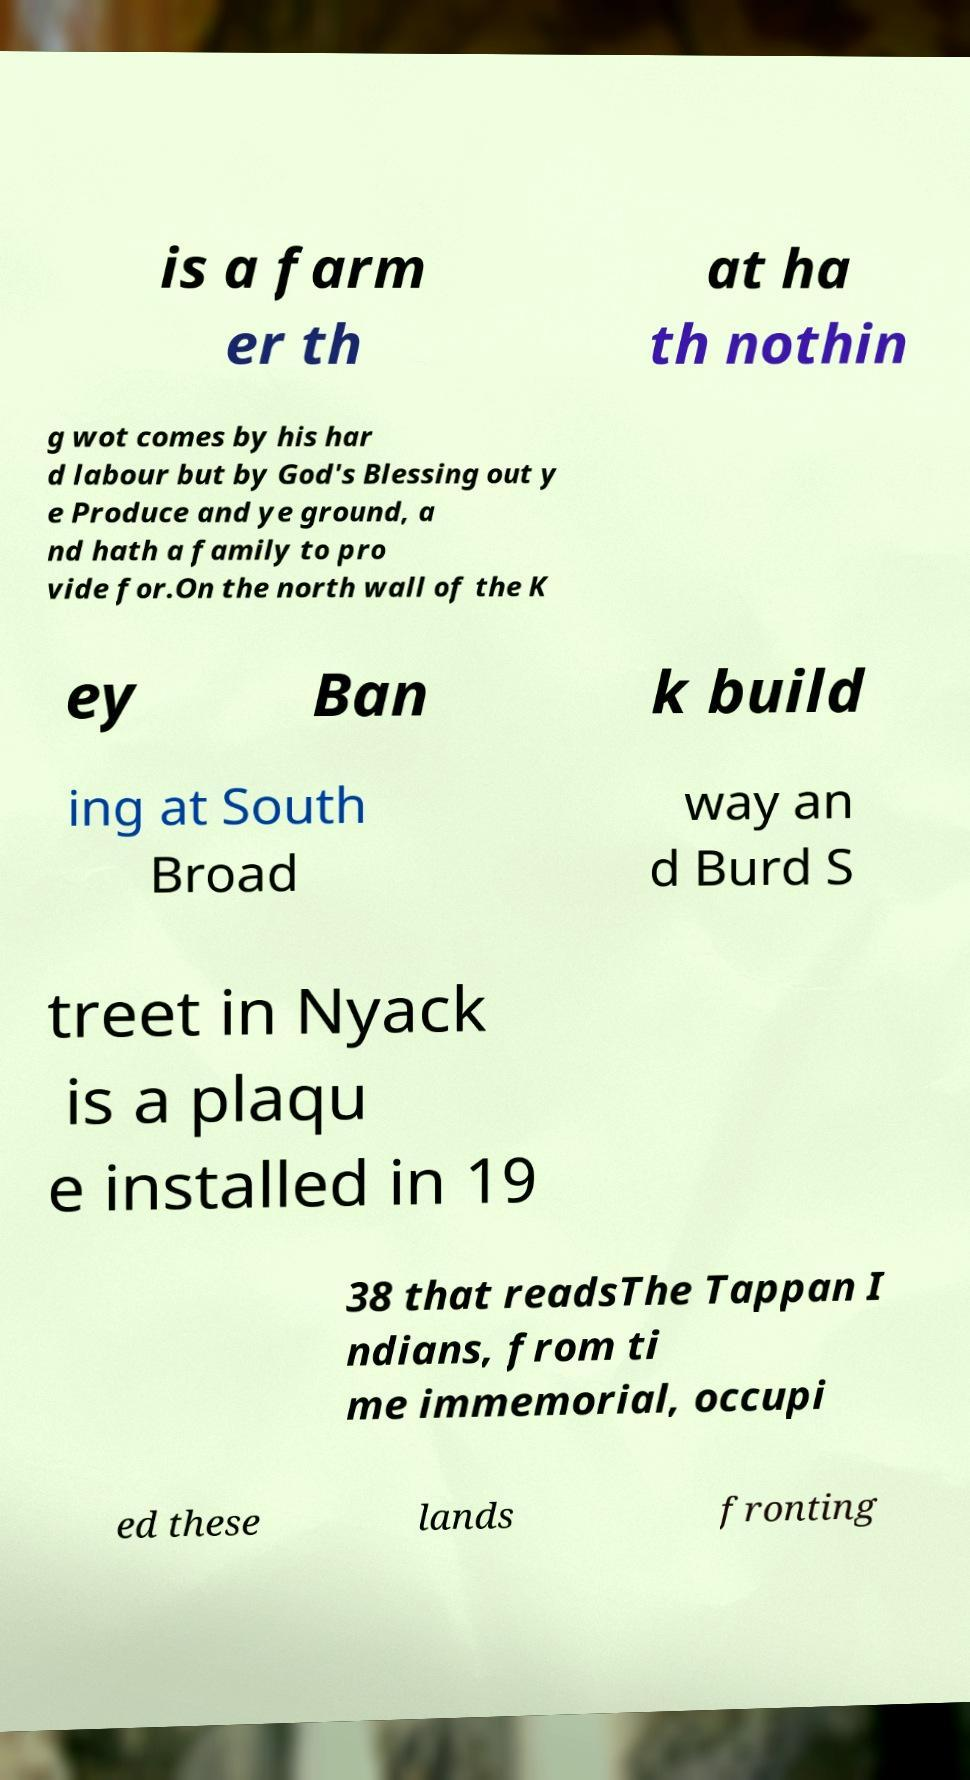Please read and relay the text visible in this image. What does it say? is a farm er th at ha th nothin g wot comes by his har d labour but by God's Blessing out y e Produce and ye ground, a nd hath a family to pro vide for.On the north wall of the K ey Ban k build ing at South Broad way an d Burd S treet in Nyack is a plaqu e installed in 19 38 that readsThe Tappan I ndians, from ti me immemorial, occupi ed these lands fronting 